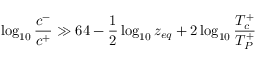Convert formula to latex. <formula><loc_0><loc_0><loc_500><loc_500>\log _ { 1 0 } { \frac { c ^ { - } } { c ^ { + } } } \gg 6 4 - { \frac { 1 } { 2 } } \log _ { 1 0 } z _ { e q } + 2 \log _ { 1 0 } { \frac { T _ { c } ^ { + } } { T _ { P } ^ { + } } }</formula> 